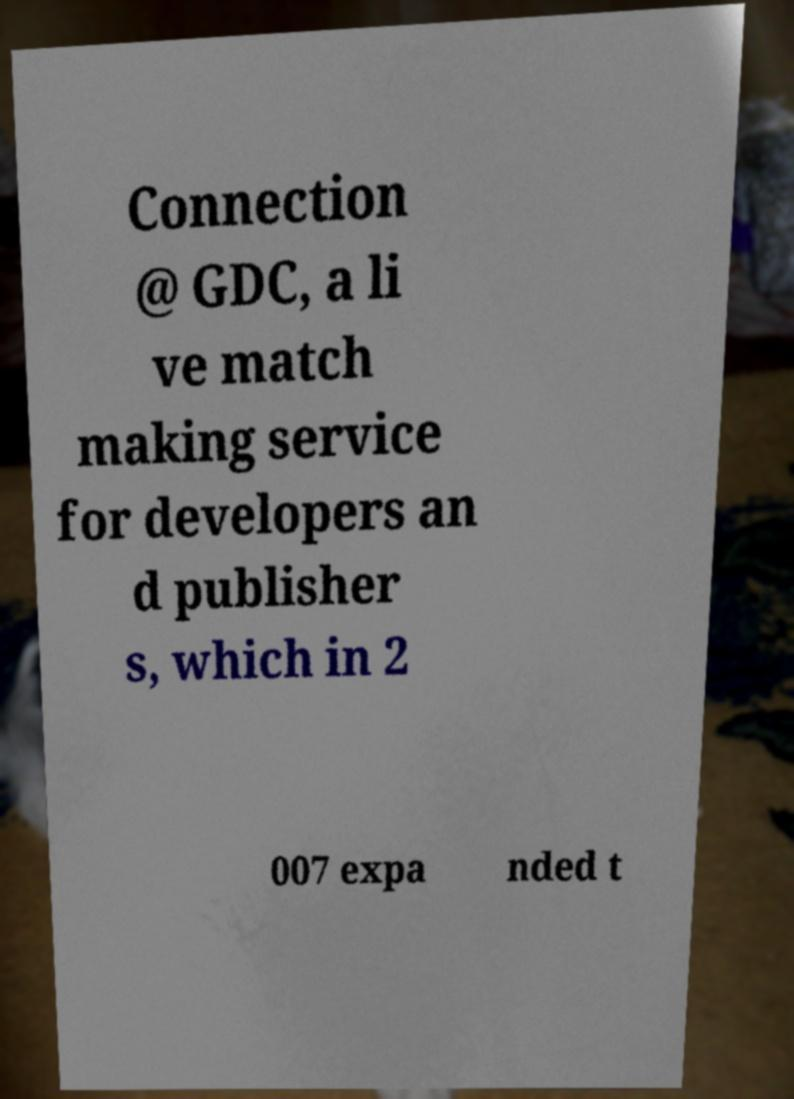There's text embedded in this image that I need extracted. Can you transcribe it verbatim? Connection @ GDC, a li ve match making service for developers an d publisher s, which in 2 007 expa nded t 